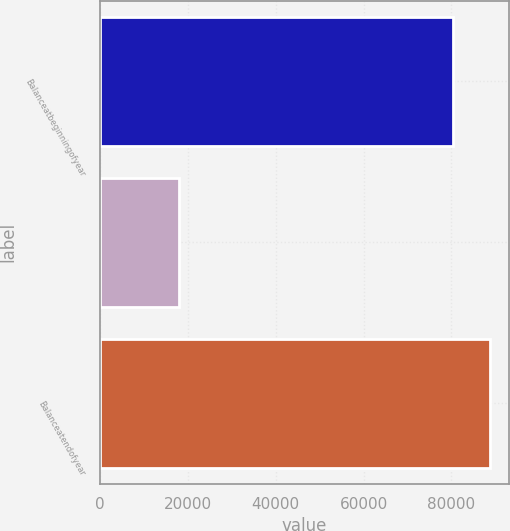<chart> <loc_0><loc_0><loc_500><loc_500><bar_chart><fcel>Balanceatbeginningofyear<fcel>Unnamed: 1<fcel>Balanceatendofyear<nl><fcel>80388<fcel>17948.8<fcel>88674.9<nl></chart> 